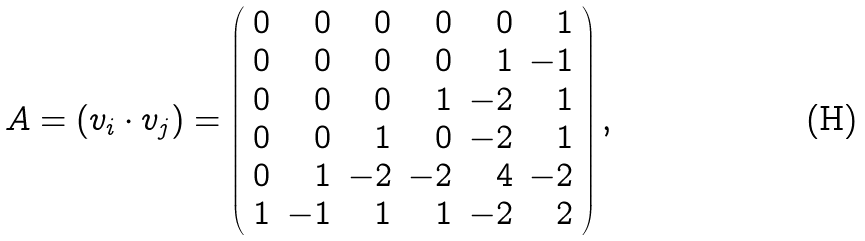Convert formula to latex. <formula><loc_0><loc_0><loc_500><loc_500>A = ( v _ { i } \cdot v _ { j } ) = \left ( \begin{array} { r r r r r r } 0 & 0 & 0 & 0 & 0 & 1 \\ 0 & 0 & 0 & 0 & 1 & - 1 \\ 0 & 0 & 0 & 1 & - 2 & 1 \\ 0 & 0 & 1 & 0 & - 2 & 1 \\ 0 & 1 & - 2 & - 2 & 4 & - 2 \\ 1 & - 1 & 1 & 1 & - 2 & 2 \end{array} \right ) ,</formula> 